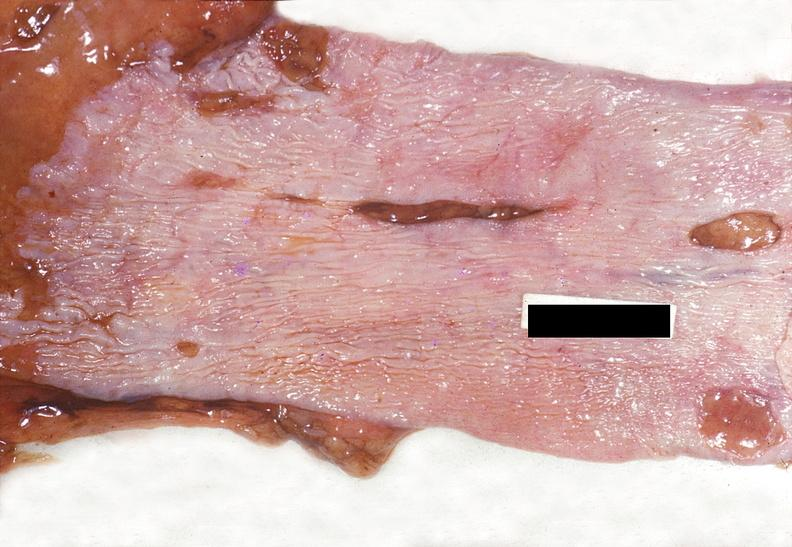what is present?
Answer the question using a single word or phrase. Gastrointestinal 